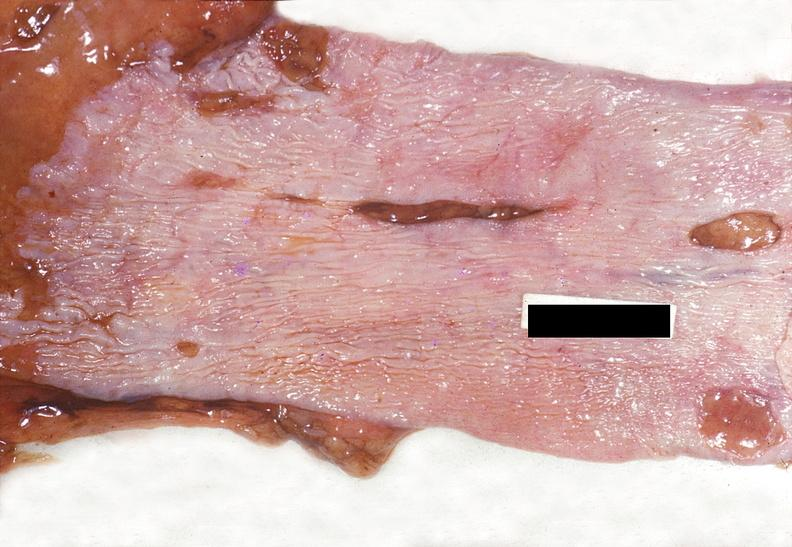what is present?
Answer the question using a single word or phrase. Gastrointestinal 